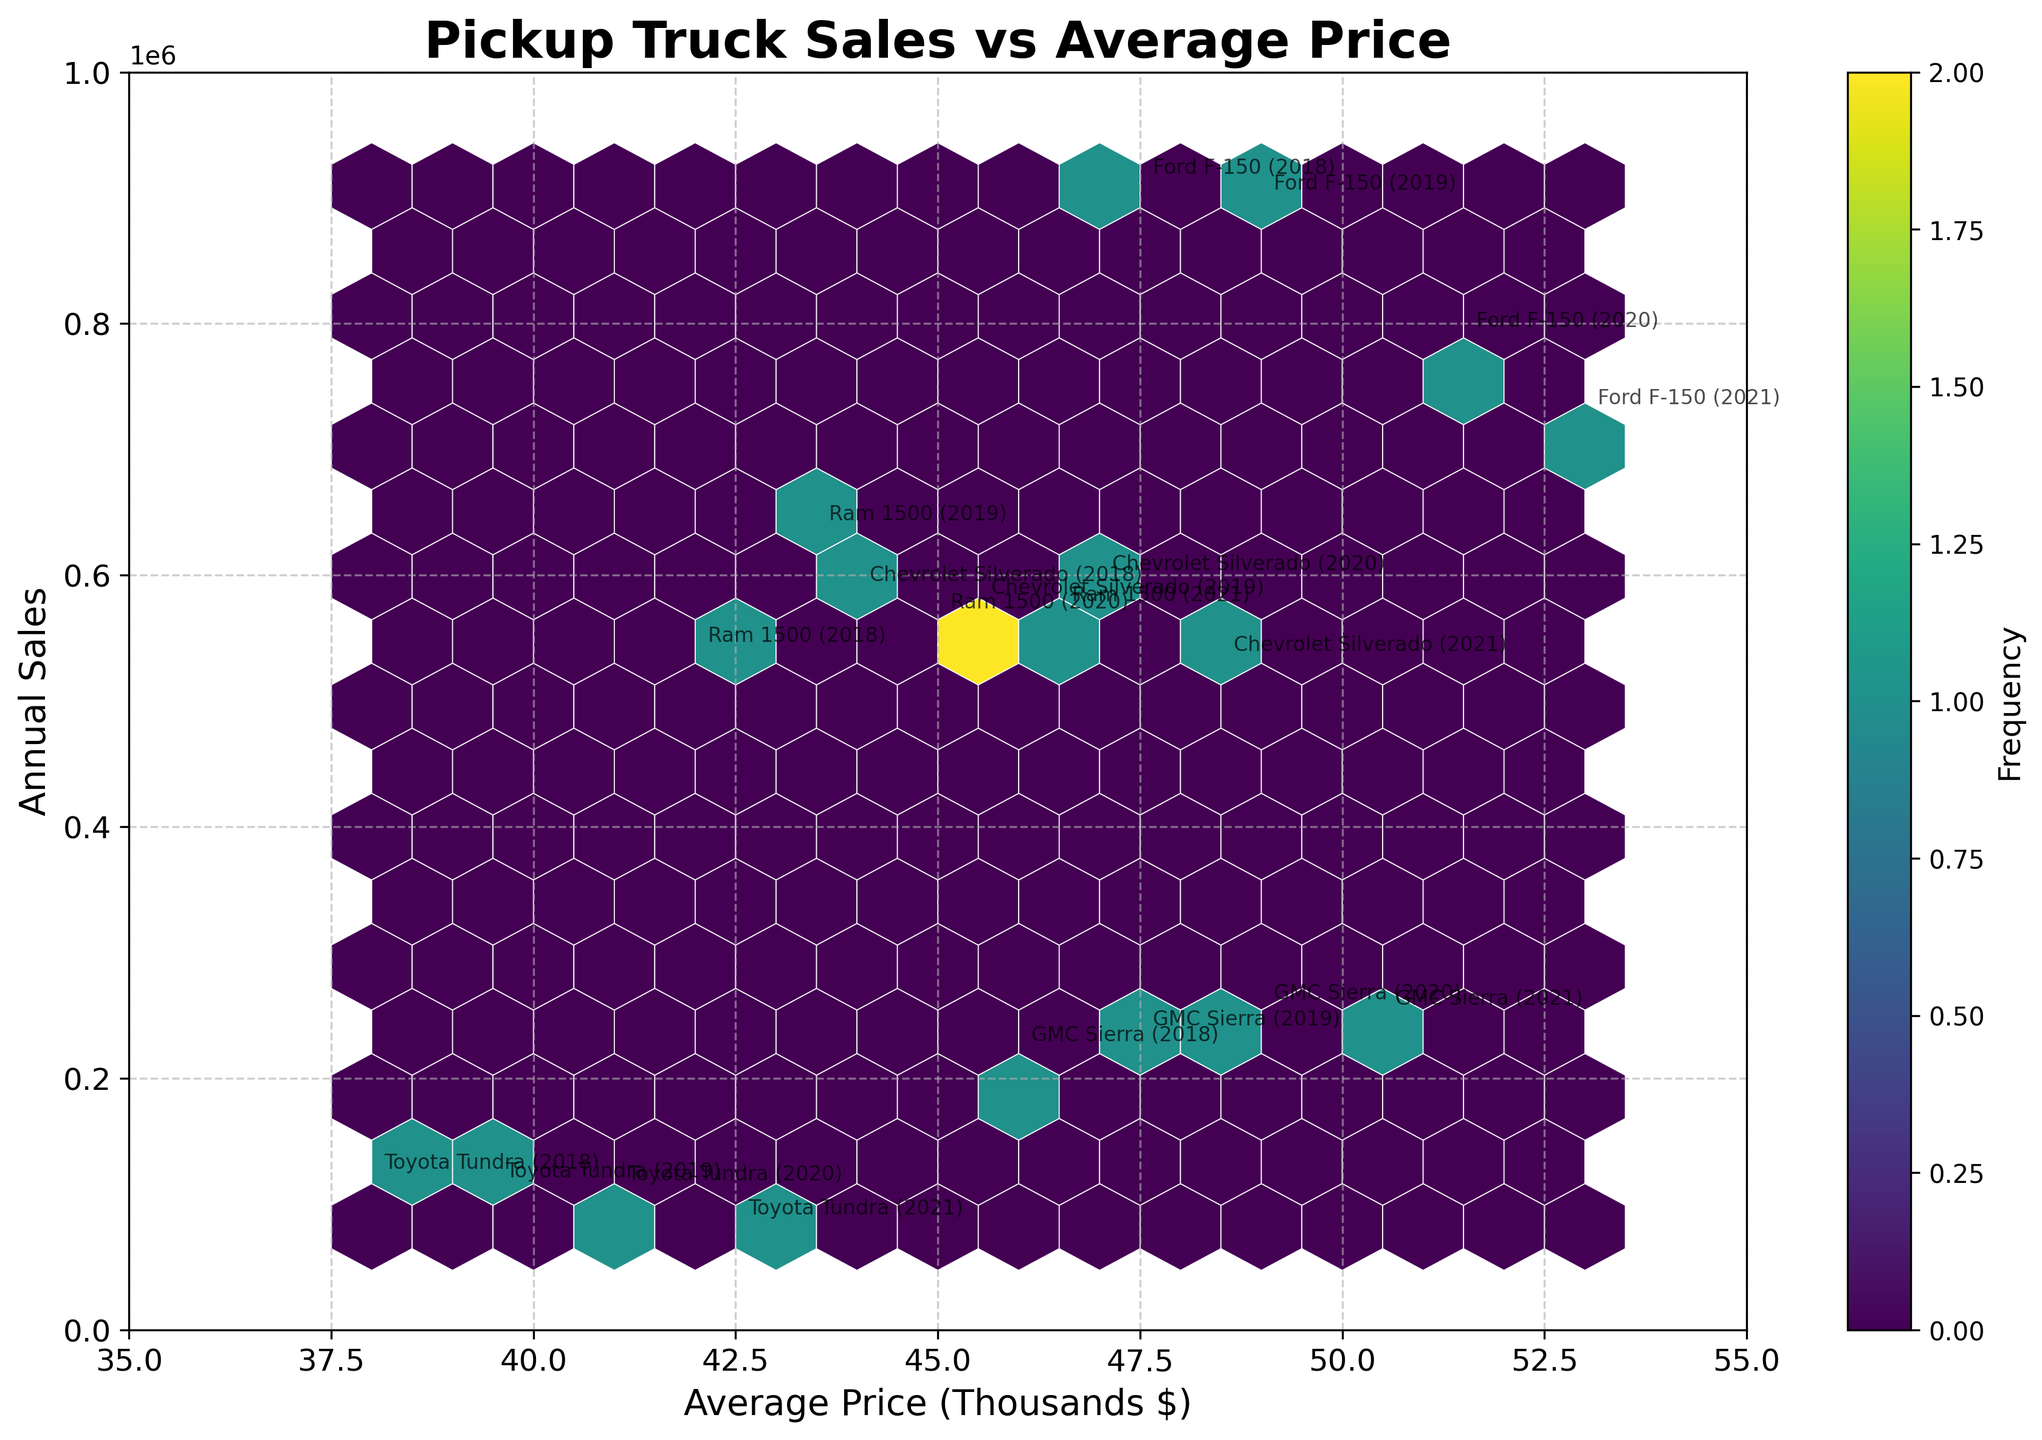What is the title of the hexbin plot? The title of the chart is usually located at the top of the plot. Here, it's clearly written as "Pickup Truck Sales vs Average Price."
Answer: Pickup Truck Sales vs Average Price What does the x-axis represent? By looking at the labeling on the horizontal axis, it's clear that the x-axis represents "Average Price" in thousands of dollars.
Answer: Average Price (Thousands $) What does the y-axis represent? The label on the vertical axis indicates that the y-axis represents the "Annual Sales" of the pickup trucks.
Answer: Annual Sales How many data points are there in the plot? By identifying the number of different hexagons and models, we see we are dealing with 5 models across 4 years, i.e., 5 models * 4 years = 20 data points.
Answer: 20 Which model appears to have the highest average price in the dataset? By looking at the annotated points on the far right of the x-axis, the "Ford F-150 (2021)" appears to have the highest average price.
Answer: Ford F-150 (2021) Which year and model combination has the highest annual sales? By checking the vertical positions and annotations, the "Ford F-150 (2018)" data point is the highest vertically, indicating the highest annual sales.
Answer: Ford F-150 (2018) Is there a general trend visible between average price and annual sales? Observing the distribution of hexagons, there seems to be a slight trend where higher prices somewhat correlate with lower sales, though it's not strictly linear.
Answer: Higher prices generally correlate with lower sales Which model-year combination has the lowest annual sales? By looking at the lowest vertical point and its annotation, the "Toyota Tundra (2021)" has the lowest annual sales.
Answer: Toyota Tundra (2021) Between the Ford F-150 and Chevrolet Silverado, which one had higher annual sales in 2020? By comparing the vertical positions of "Ford F-150 (2020)" and "Chevrolet Silverado (2020)," the Ford F-150 is higher, indicating it had higher annual sales.
Answer: Ford F-150 What is the approximate average price for GMC Sierra in 2021? The GMC Sierra (2021) is annotated at a point where the x-axis value is close to $50,500, which is the approximate average price in that year.
Answer: $50,500 